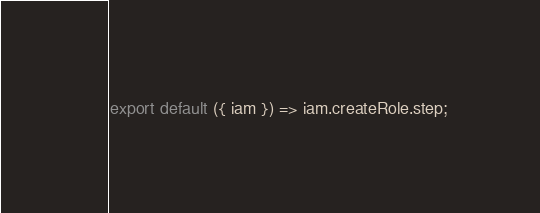Convert code to text. <code><loc_0><loc_0><loc_500><loc_500><_JavaScript_>export default ({ iam }) => iam.createRole.step;
</code> 